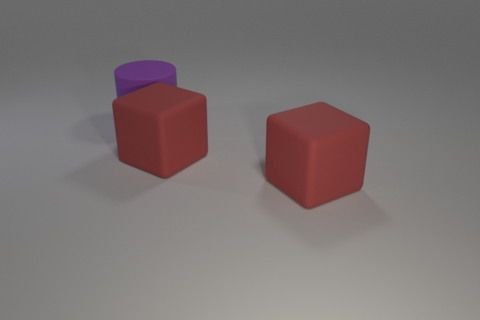How many matte things are either blocks or big purple objects?
Offer a terse response. 3. What is the shape of the big purple rubber thing?
Your answer should be very brief. Cylinder. What number of things are either tiny gray shiny cylinders or things in front of the purple cylinder?
Ensure brevity in your answer.  2. What number of red things are either matte cylinders or large objects?
Keep it short and to the point. 2. Is the number of red things that are behind the purple thing greater than the number of big gray rubber things?
Your response must be concise. No. What number of cylinders have the same size as the purple thing?
Give a very brief answer. 0. What number of red things have the same shape as the large purple thing?
Your response must be concise. 0. Is there a large red cube that has the same material as the big purple cylinder?
Offer a very short reply. Yes. What number of red cubes are there?
Keep it short and to the point. 2. How many spheres are purple rubber things or red things?
Your answer should be compact. 0. 